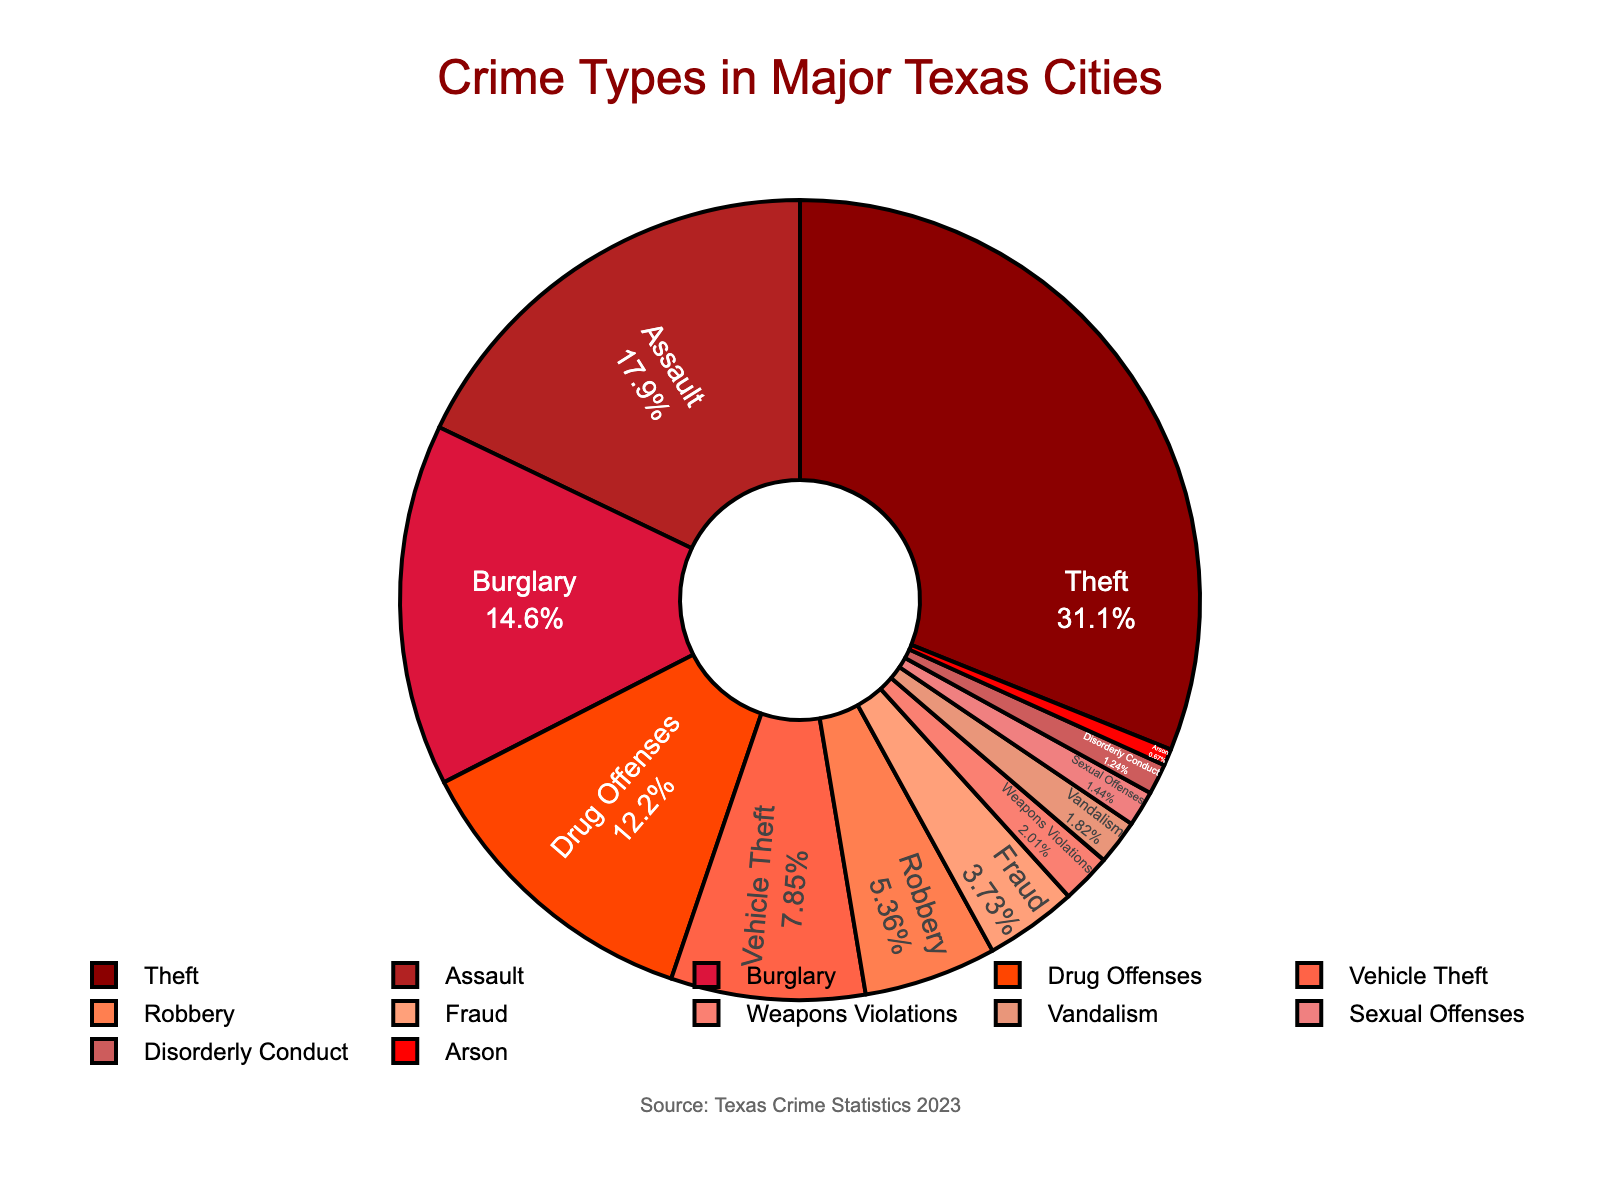What's the most common type of crime in major Texas cities? The pie chart shows the percentage distribution of different crime types. The largest section corresponds to theft, marked as 32.5%.
Answer: Theft What percentage of crimes does assault make up in major Texas cities? By examining the pie chart, the segment labeled "Assault" shows a percentage of 18.7%.
Answer: 18.7% Is vehicle theft more or less frequent than burglary in major Texas cities? Comparing the segments labeled "Vehicle Theft" and "Burglary," vehicle theft has 8.2%, and burglary has 15.3%. Therefore, vehicle theft is less frequent.
Answer: Less frequent What is the total percentage for non-violent crimes (Theft, Burglary, Fraud, Vandalism, and Vehicle Theft)? Non-violent crimes are Theft (32.5%), Burglary (15.3%), Fraud (3.9%), Vandalism (1.9%), and Vehicle Theft (8.2%). Summing them up: 32.5 + 15.3 + 3.9 + 1.9 + 8.2 = 61.8%.
Answer: 61.8% Are sexual offenses the least common type of crime shown on the chart? By looking at the chart segments, the smallest section corresponds to Arson at 0.7%, which is smaller than Sexual Offenses at 1.5%.
Answer: No What is the difference in percentage between drug offenses and weapon violations? Drug Offenses are labeled as 12.8% and Weapon Violations as 2.1%. The difference is 12.8 - 2.1 = 10.7%.
Answer: 10.7% How does the percentage of robbery compare to arson and disorderly conduct combined? Robbery is labeled as 5.6%. Arson is 0.7% and Disorderly Conduct is 1.3%. Combined, they are 0.7 + 1.3 = 2%. Robbery is greater at 5.6%.
Answer: Greater Which type of crime has a percentage closest to 10%? The only type of crime near 10% is Drug Offenses, labeled as 12.8%.
Answer: Drug Offenses What visual features are used to represent different types of crimes in the chart? The chart uses different colors for each crime type, segments with percentages, and labels positioned inside the sections, displaying the crime type and its percentage.
Answer: Colors, labels, percentages What portion of the crimes represented fall into the broad category of violent crimes (Assault, Sexual Offenses, Robbery, and Weapons Violations)? Violent crimes include Assault (18.7%), Sexual Offenses (1.5%), Robbery (5.6%), and Weapons Violations (2.1%). Summing them up: 18.7 + 1.5 + 5.6 + 2.1 = 27.9%.
Answer: 27.9% 